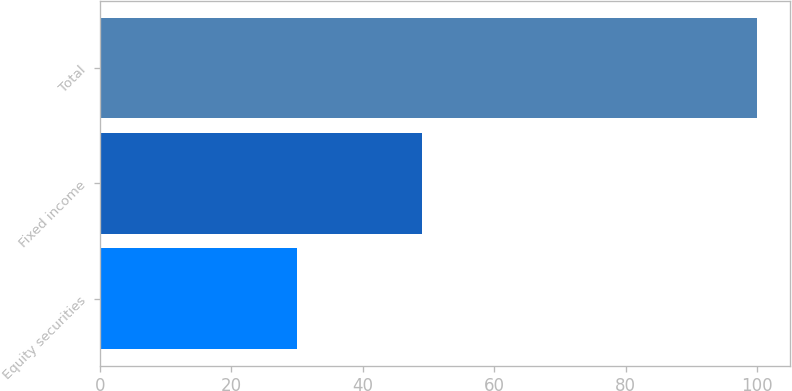<chart> <loc_0><loc_0><loc_500><loc_500><bar_chart><fcel>Equity securities<fcel>Fixed income<fcel>Total<nl><fcel>30<fcel>49<fcel>100<nl></chart> 